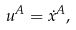<formula> <loc_0><loc_0><loc_500><loc_500>u ^ { A } = \dot { x } ^ { A } ,</formula> 